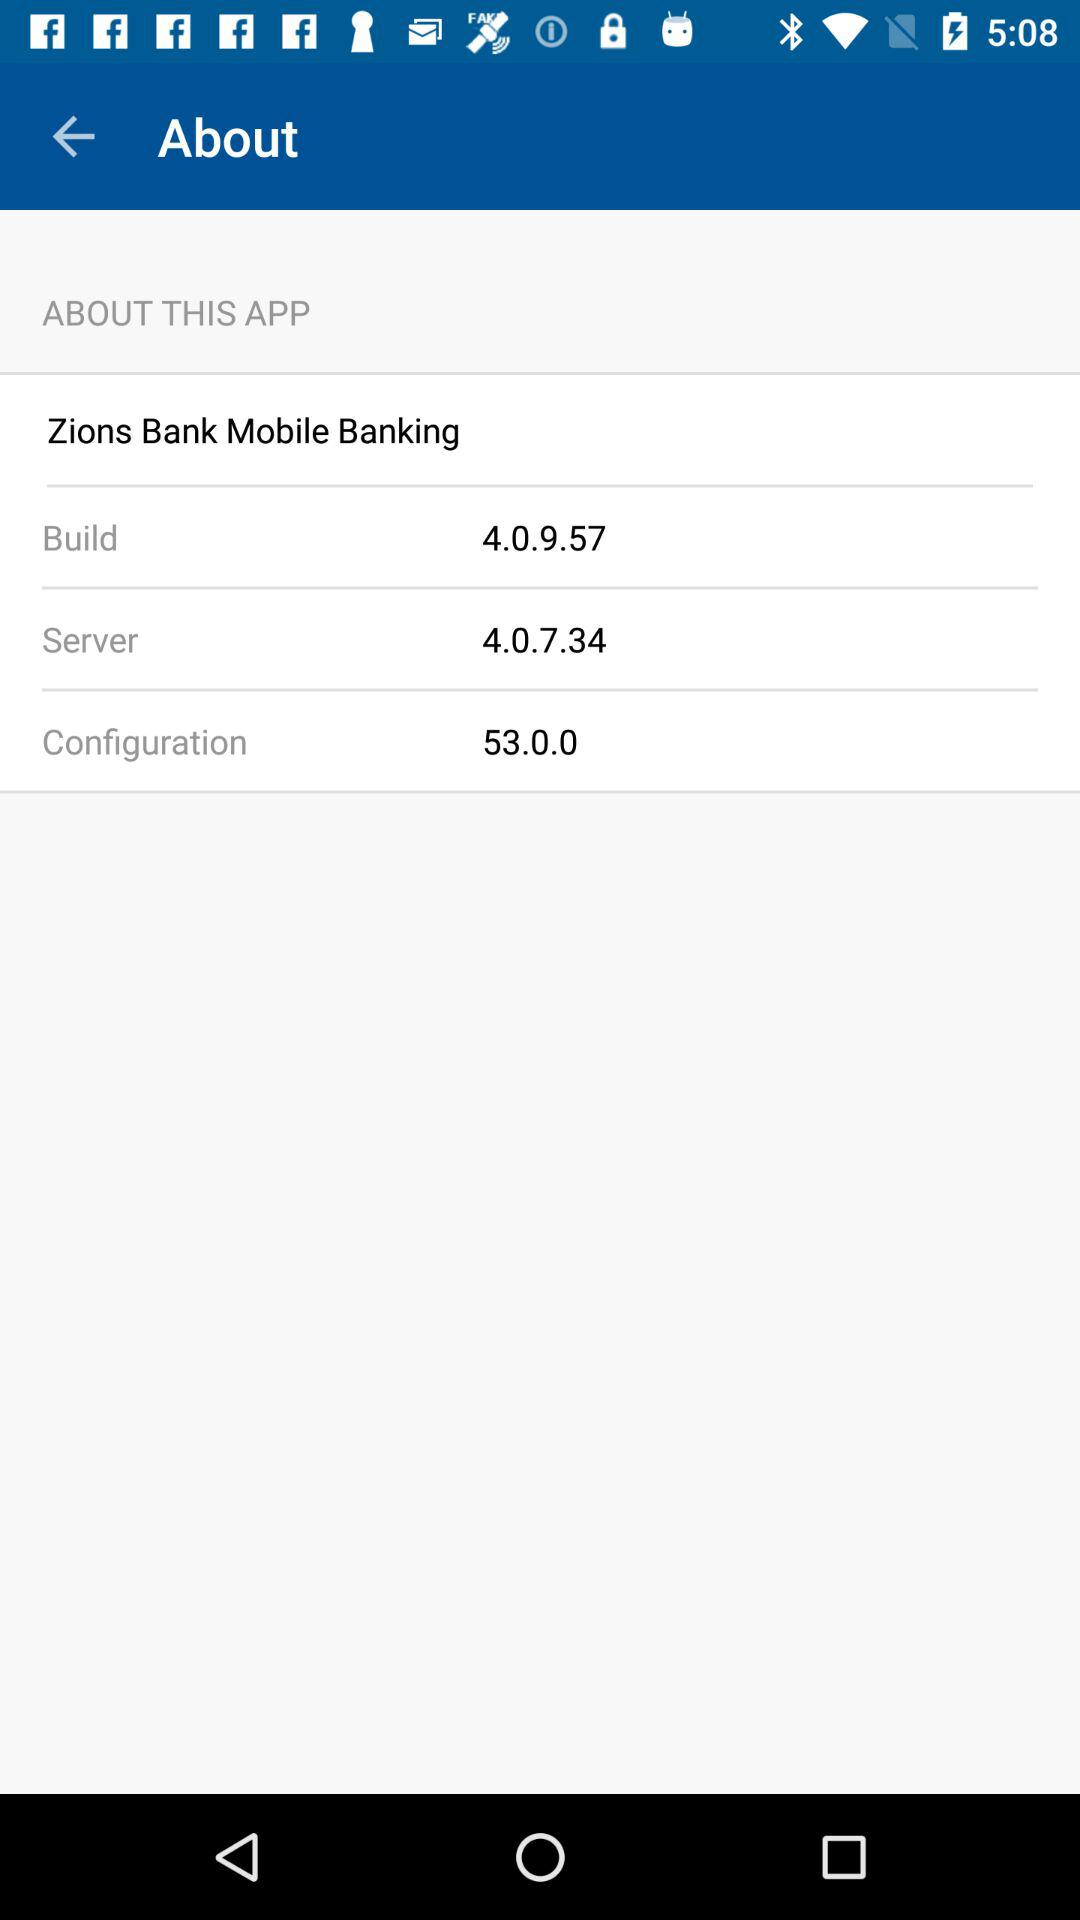What is the version of the configuration?
Answer the question using a single word or phrase. 53.0.0 